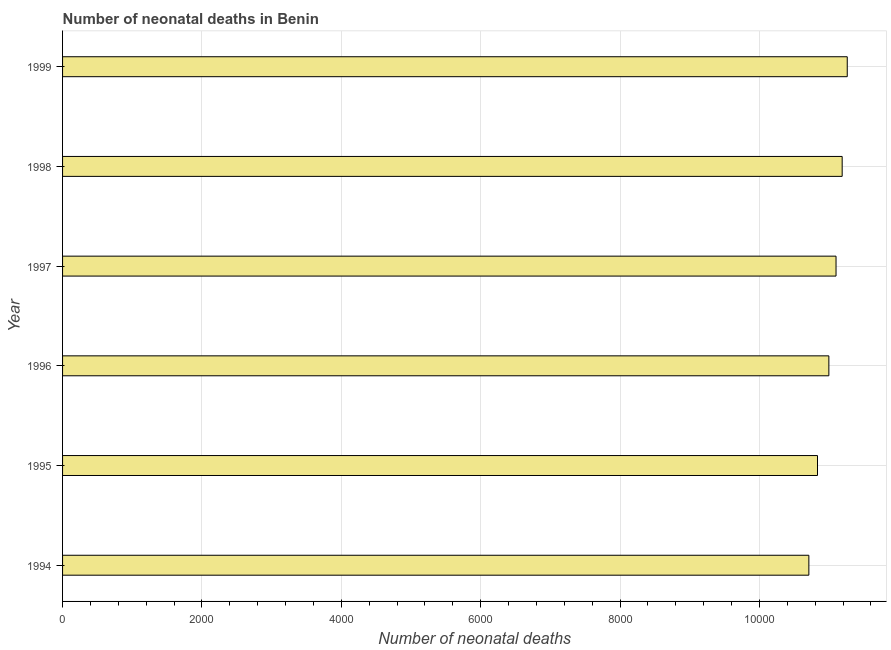Does the graph contain any zero values?
Provide a succinct answer. No. What is the title of the graph?
Offer a terse response. Number of neonatal deaths in Benin. What is the label or title of the X-axis?
Make the answer very short. Number of neonatal deaths. What is the label or title of the Y-axis?
Give a very brief answer. Year. What is the number of neonatal deaths in 1996?
Provide a short and direct response. 1.10e+04. Across all years, what is the maximum number of neonatal deaths?
Offer a terse response. 1.13e+04. Across all years, what is the minimum number of neonatal deaths?
Your response must be concise. 1.07e+04. What is the sum of the number of neonatal deaths?
Give a very brief answer. 6.61e+04. What is the difference between the number of neonatal deaths in 1995 and 1997?
Your answer should be very brief. -266. What is the average number of neonatal deaths per year?
Your answer should be compact. 1.10e+04. What is the median number of neonatal deaths?
Your answer should be very brief. 1.10e+04. Do a majority of the years between 1998 and 1997 (inclusive) have number of neonatal deaths greater than 5600 ?
Your answer should be very brief. No. Is the number of neonatal deaths in 1996 less than that in 1999?
Keep it short and to the point. Yes. Is the sum of the number of neonatal deaths in 1994 and 1999 greater than the maximum number of neonatal deaths across all years?
Your response must be concise. Yes. What is the difference between the highest and the lowest number of neonatal deaths?
Make the answer very short. 551. In how many years, is the number of neonatal deaths greater than the average number of neonatal deaths taken over all years?
Ensure brevity in your answer.  3. How many bars are there?
Make the answer very short. 6. Are all the bars in the graph horizontal?
Provide a succinct answer. Yes. What is the difference between two consecutive major ticks on the X-axis?
Your answer should be compact. 2000. What is the Number of neonatal deaths in 1994?
Offer a very short reply. 1.07e+04. What is the Number of neonatal deaths in 1995?
Give a very brief answer. 1.08e+04. What is the Number of neonatal deaths of 1996?
Make the answer very short. 1.10e+04. What is the Number of neonatal deaths in 1997?
Provide a succinct answer. 1.11e+04. What is the Number of neonatal deaths in 1998?
Give a very brief answer. 1.12e+04. What is the Number of neonatal deaths in 1999?
Your response must be concise. 1.13e+04. What is the difference between the Number of neonatal deaths in 1994 and 1995?
Offer a very short reply. -124. What is the difference between the Number of neonatal deaths in 1994 and 1996?
Provide a short and direct response. -287. What is the difference between the Number of neonatal deaths in 1994 and 1997?
Provide a succinct answer. -390. What is the difference between the Number of neonatal deaths in 1994 and 1998?
Give a very brief answer. -478. What is the difference between the Number of neonatal deaths in 1994 and 1999?
Make the answer very short. -551. What is the difference between the Number of neonatal deaths in 1995 and 1996?
Provide a short and direct response. -163. What is the difference between the Number of neonatal deaths in 1995 and 1997?
Your response must be concise. -266. What is the difference between the Number of neonatal deaths in 1995 and 1998?
Your answer should be compact. -354. What is the difference between the Number of neonatal deaths in 1995 and 1999?
Keep it short and to the point. -427. What is the difference between the Number of neonatal deaths in 1996 and 1997?
Provide a succinct answer. -103. What is the difference between the Number of neonatal deaths in 1996 and 1998?
Keep it short and to the point. -191. What is the difference between the Number of neonatal deaths in 1996 and 1999?
Your answer should be very brief. -264. What is the difference between the Number of neonatal deaths in 1997 and 1998?
Give a very brief answer. -88. What is the difference between the Number of neonatal deaths in 1997 and 1999?
Keep it short and to the point. -161. What is the difference between the Number of neonatal deaths in 1998 and 1999?
Give a very brief answer. -73. What is the ratio of the Number of neonatal deaths in 1994 to that in 1997?
Make the answer very short. 0.96. What is the ratio of the Number of neonatal deaths in 1994 to that in 1998?
Offer a terse response. 0.96. What is the ratio of the Number of neonatal deaths in 1994 to that in 1999?
Give a very brief answer. 0.95. What is the ratio of the Number of neonatal deaths in 1995 to that in 1996?
Keep it short and to the point. 0.98. What is the ratio of the Number of neonatal deaths in 1995 to that in 1997?
Your response must be concise. 0.98. What is the ratio of the Number of neonatal deaths in 1995 to that in 1998?
Your answer should be very brief. 0.97. What is the ratio of the Number of neonatal deaths in 1995 to that in 1999?
Offer a terse response. 0.96. What is the ratio of the Number of neonatal deaths in 1996 to that in 1998?
Ensure brevity in your answer.  0.98. What is the ratio of the Number of neonatal deaths in 1997 to that in 1998?
Offer a terse response. 0.99. What is the ratio of the Number of neonatal deaths in 1997 to that in 1999?
Your response must be concise. 0.99. 